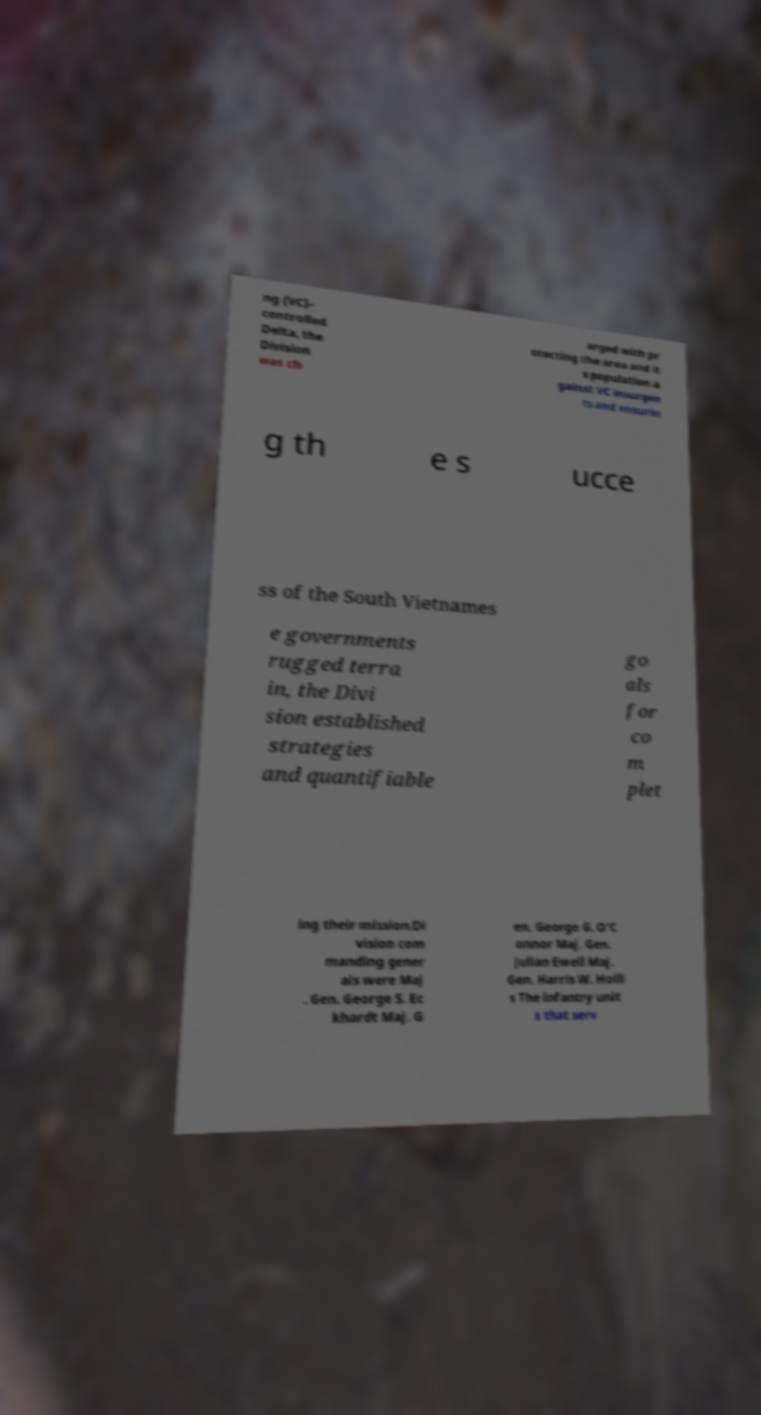For documentation purposes, I need the text within this image transcribed. Could you provide that? ng (VC)– controlled Delta, the Division was ch arged with pr otecting the area and it s population a gainst VC insurgen ts and ensurin g th e s ucce ss of the South Vietnames e governments rugged terra in, the Divi sion established strategies and quantifiable go als for co m plet ing their mission.Di vision com manding gener als were Maj . Gen. George S. Ec khardt Maj. G en. George G. O'C onnor Maj. Gen. Julian Ewell Maj. Gen. Harris W. Holli s The infantry unit s that serv 